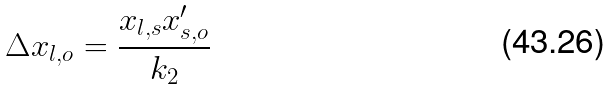Convert formula to latex. <formula><loc_0><loc_0><loc_500><loc_500>\Delta x _ { l , o } = \frac { x _ { l , s } x _ { s , o } ^ { \prime } } { k _ { 2 } }</formula> 